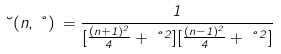<formula> <loc_0><loc_0><loc_500><loc_500>\lambda ( n , \nu ) \, = \frac { 1 } { [ \frac { ( n + 1 ) ^ { 2 } } { 4 } + \nu ^ { 2 } ] [ \frac { ( n - 1 ) ^ { 2 } } { 4 } + \nu ^ { 2 } ] }</formula> 